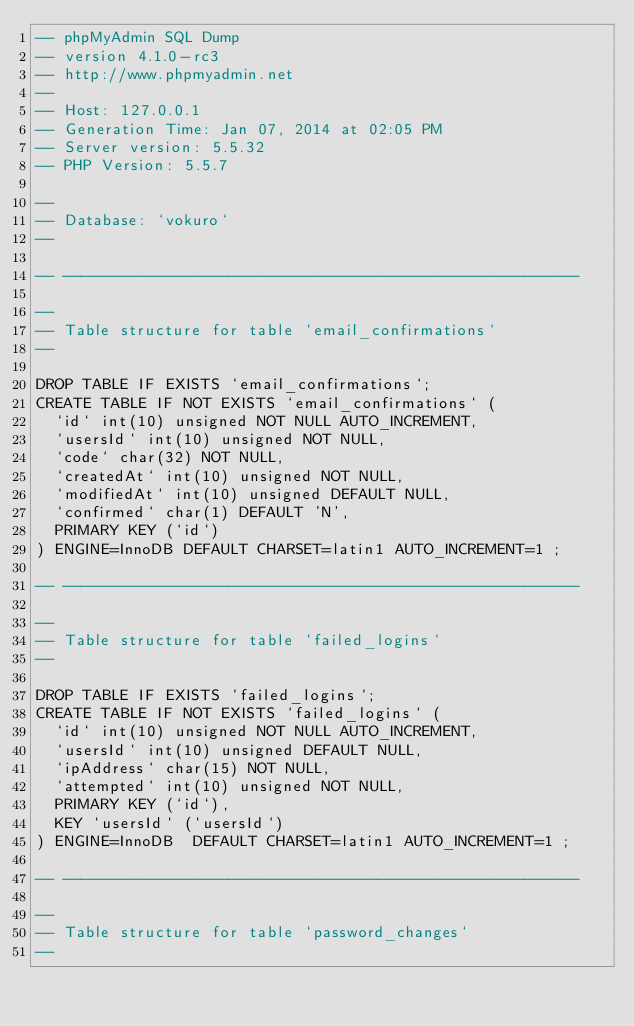<code> <loc_0><loc_0><loc_500><loc_500><_SQL_>-- phpMyAdmin SQL Dump
-- version 4.1.0-rc3
-- http://www.phpmyadmin.net
--
-- Host: 127.0.0.1
-- Generation Time: Jan 07, 2014 at 02:05 PM
-- Server version: 5.5.32
-- PHP Version: 5.5.7

--
-- Database: `vokuro`
--

-- --------------------------------------------------------

--
-- Table structure for table `email_confirmations`
--

DROP TABLE IF EXISTS `email_confirmations`;
CREATE TABLE IF NOT EXISTS `email_confirmations` (
  `id` int(10) unsigned NOT NULL AUTO_INCREMENT,
  `usersId` int(10) unsigned NOT NULL,
  `code` char(32) NOT NULL,
  `createdAt` int(10) unsigned NOT NULL,
  `modifiedAt` int(10) unsigned DEFAULT NULL,
  `confirmed` char(1) DEFAULT 'N',
  PRIMARY KEY (`id`)
) ENGINE=InnoDB DEFAULT CHARSET=latin1 AUTO_INCREMENT=1 ;

-- --------------------------------------------------------

--
-- Table structure for table `failed_logins`
--

DROP TABLE IF EXISTS `failed_logins`;
CREATE TABLE IF NOT EXISTS `failed_logins` (
  `id` int(10) unsigned NOT NULL AUTO_INCREMENT,
  `usersId` int(10) unsigned DEFAULT NULL,
  `ipAddress` char(15) NOT NULL,
  `attempted` int(10) unsigned NOT NULL,
  PRIMARY KEY (`id`),
  KEY `usersId` (`usersId`)
) ENGINE=InnoDB  DEFAULT CHARSET=latin1 AUTO_INCREMENT=1 ;

-- --------------------------------------------------------

--
-- Table structure for table `password_changes`
--
</code> 